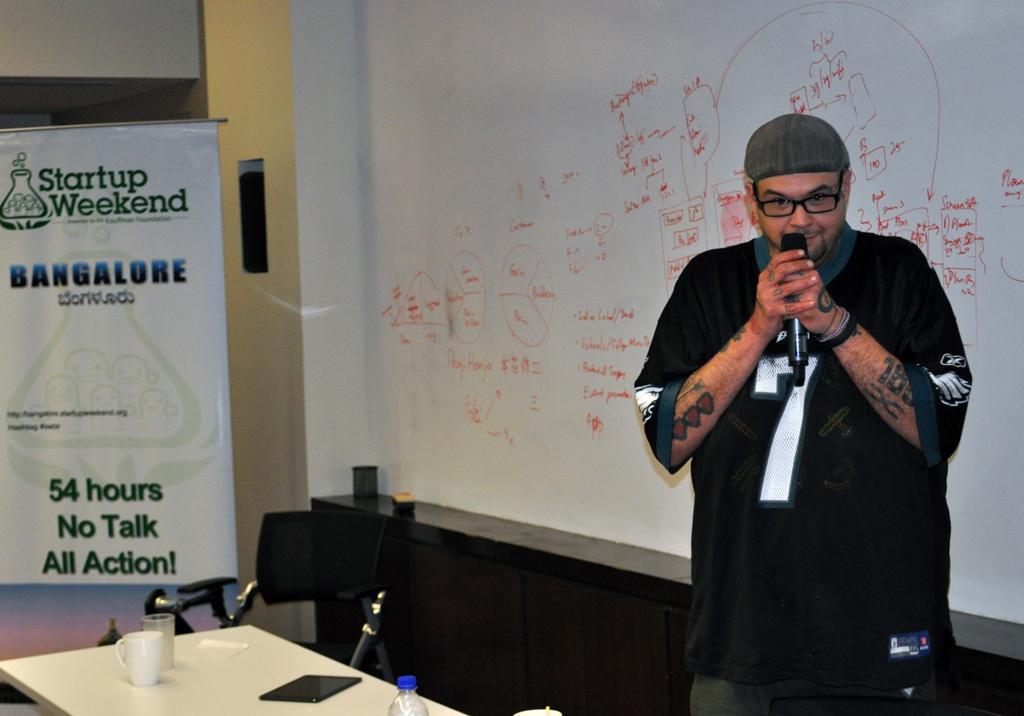How would you summarize this image in a sentence or two? Here is a person holding a mike wearing a glasses, in front of him there is a table in which a cup, a glass and a tab is present on it and a chair is there. Behind him a white wall is present where some text is written. Beside him one hoarding is there. 